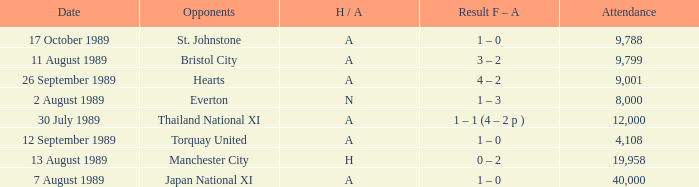When did manchester united encounter bristol city with an h/a of a? 11 August 1989. 